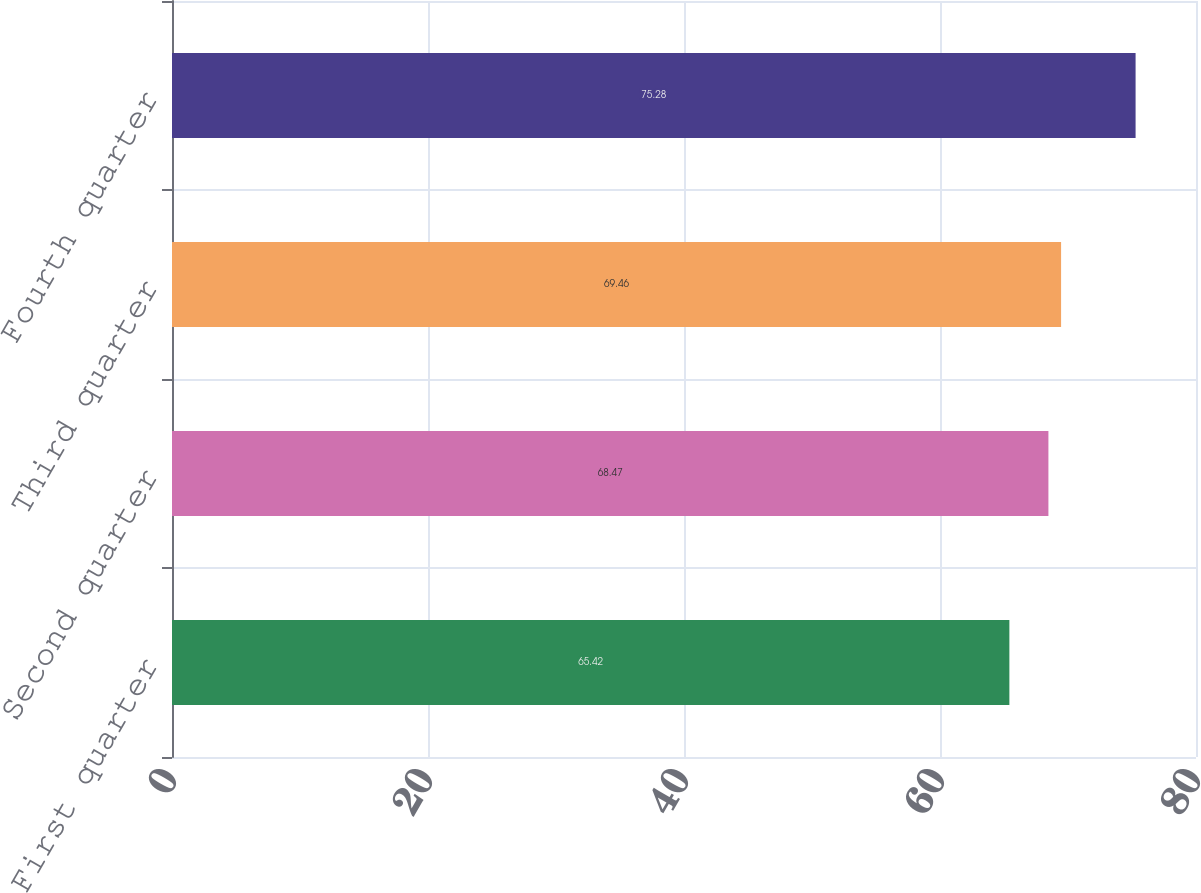Convert chart to OTSL. <chart><loc_0><loc_0><loc_500><loc_500><bar_chart><fcel>First quarter<fcel>Second quarter<fcel>Third quarter<fcel>Fourth quarter<nl><fcel>65.42<fcel>68.47<fcel>69.46<fcel>75.28<nl></chart> 